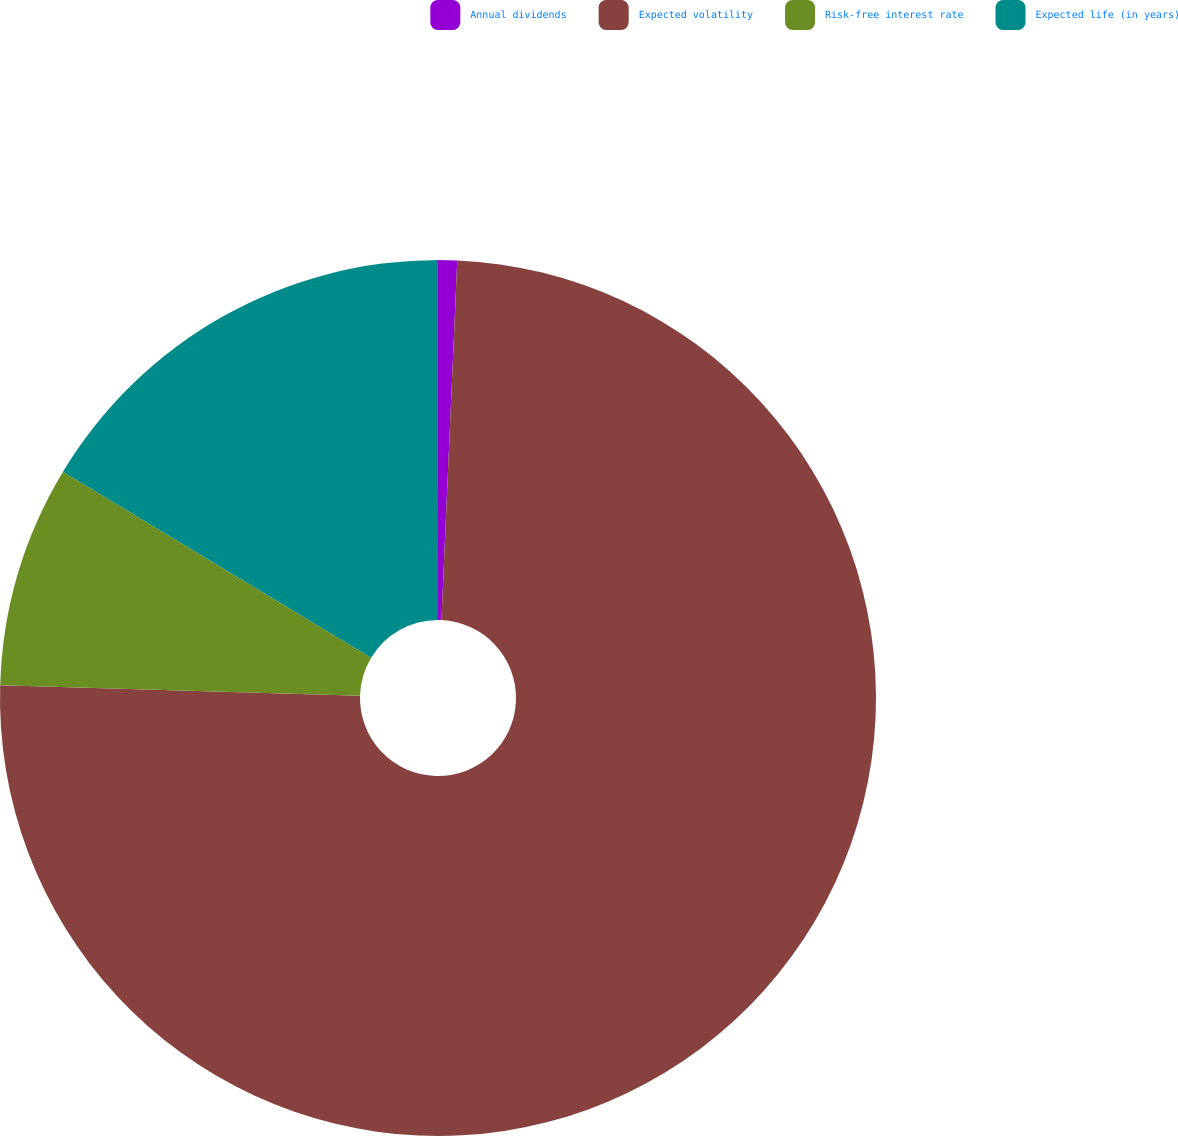Convert chart. <chart><loc_0><loc_0><loc_500><loc_500><pie_chart><fcel>Annual dividends<fcel>Expected volatility<fcel>Risk-free interest rate<fcel>Expected life (in years)<nl><fcel>0.7%<fcel>74.77%<fcel>8.18%<fcel>16.36%<nl></chart> 